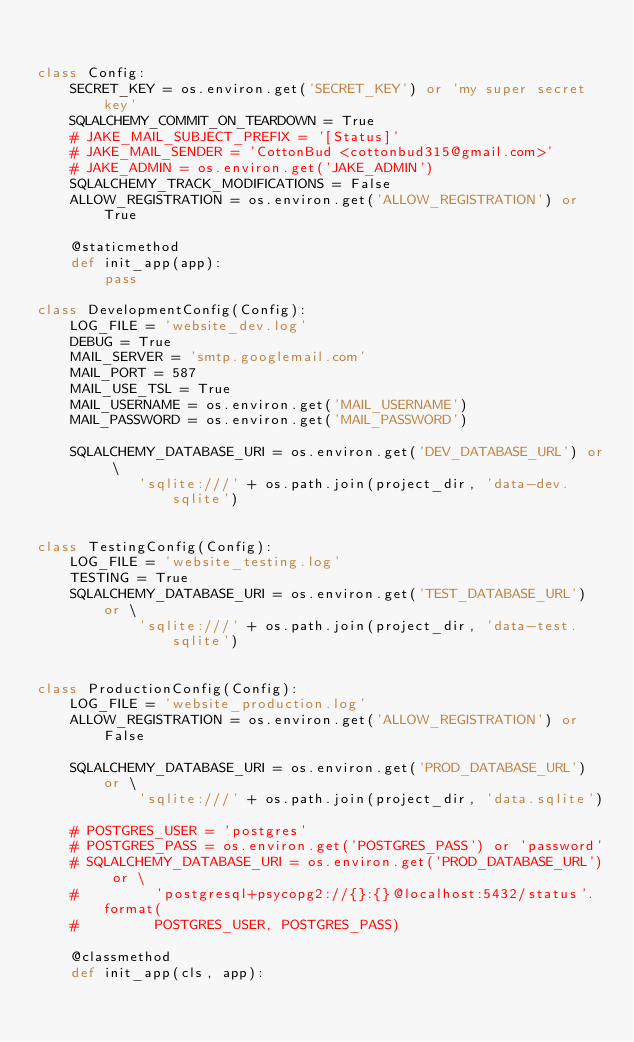Convert code to text. <code><loc_0><loc_0><loc_500><loc_500><_Python_>

class Config:
    SECRET_KEY = os.environ.get('SECRET_KEY') or 'my super secret key'
    SQLALCHEMY_COMMIT_ON_TEARDOWN = True
    # JAKE_MAIL_SUBJECT_PREFIX = '[Status]'
    # JAKE_MAIL_SENDER = 'CottonBud <cottonbud315@gmail.com>'
    # JAKE_ADMIN = os.environ.get('JAKE_ADMIN')
    SQLALCHEMY_TRACK_MODIFICATIONS = False
    ALLOW_REGISTRATION = os.environ.get('ALLOW_REGISTRATION') or True

    @staticmethod
    def init_app(app):
        pass

class DevelopmentConfig(Config):
    LOG_FILE = 'website_dev.log'
    DEBUG = True
    MAIL_SERVER = 'smtp.googlemail.com'
    MAIL_PORT = 587
    MAIL_USE_TSL = True
    MAIL_USERNAME = os.environ.get('MAIL_USERNAME')
    MAIL_PASSWORD = os.environ.get('MAIL_PASSWORD')

    SQLALCHEMY_DATABASE_URI = os.environ.get('DEV_DATABASE_URL') or \
            'sqlite:///' + os.path.join(project_dir, 'data-dev.sqlite')


class TestingConfig(Config):
    LOG_FILE = 'website_testing.log'
    TESTING = True
    SQLALCHEMY_DATABASE_URI = os.environ.get('TEST_DATABASE_URL') or \
            'sqlite:///' + os.path.join(project_dir, 'data-test.sqlite')


class ProductionConfig(Config):
    LOG_FILE = 'website_production.log'
    ALLOW_REGISTRATION = os.environ.get('ALLOW_REGISTRATION') or False

    SQLALCHEMY_DATABASE_URI = os.environ.get('PROD_DATABASE_URL') or \
            'sqlite:///' + os.path.join(project_dir, 'data.sqlite')

    # POSTGRES_USER = 'postgres'
    # POSTGRES_PASS = os.environ.get('POSTGRES_PASS') or 'password'
    # SQLALCHEMY_DATABASE_URI = os.environ.get('PROD_DATABASE_URL') or \
    #         'postgresql+psycopg2://{}:{}@localhost:5432/status'.format(
    #         POSTGRES_USER, POSTGRES_PASS)

    @classmethod
    def init_app(cls, app):</code> 